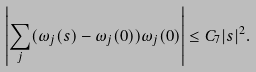Convert formula to latex. <formula><loc_0><loc_0><loc_500><loc_500>\left | \sum _ { j } ( \omega _ { j } ( s ) - \omega _ { j } ( 0 ) ) \omega _ { j } ( 0 ) \right | \leq C _ { 7 } | s | ^ { 2 } .</formula> 